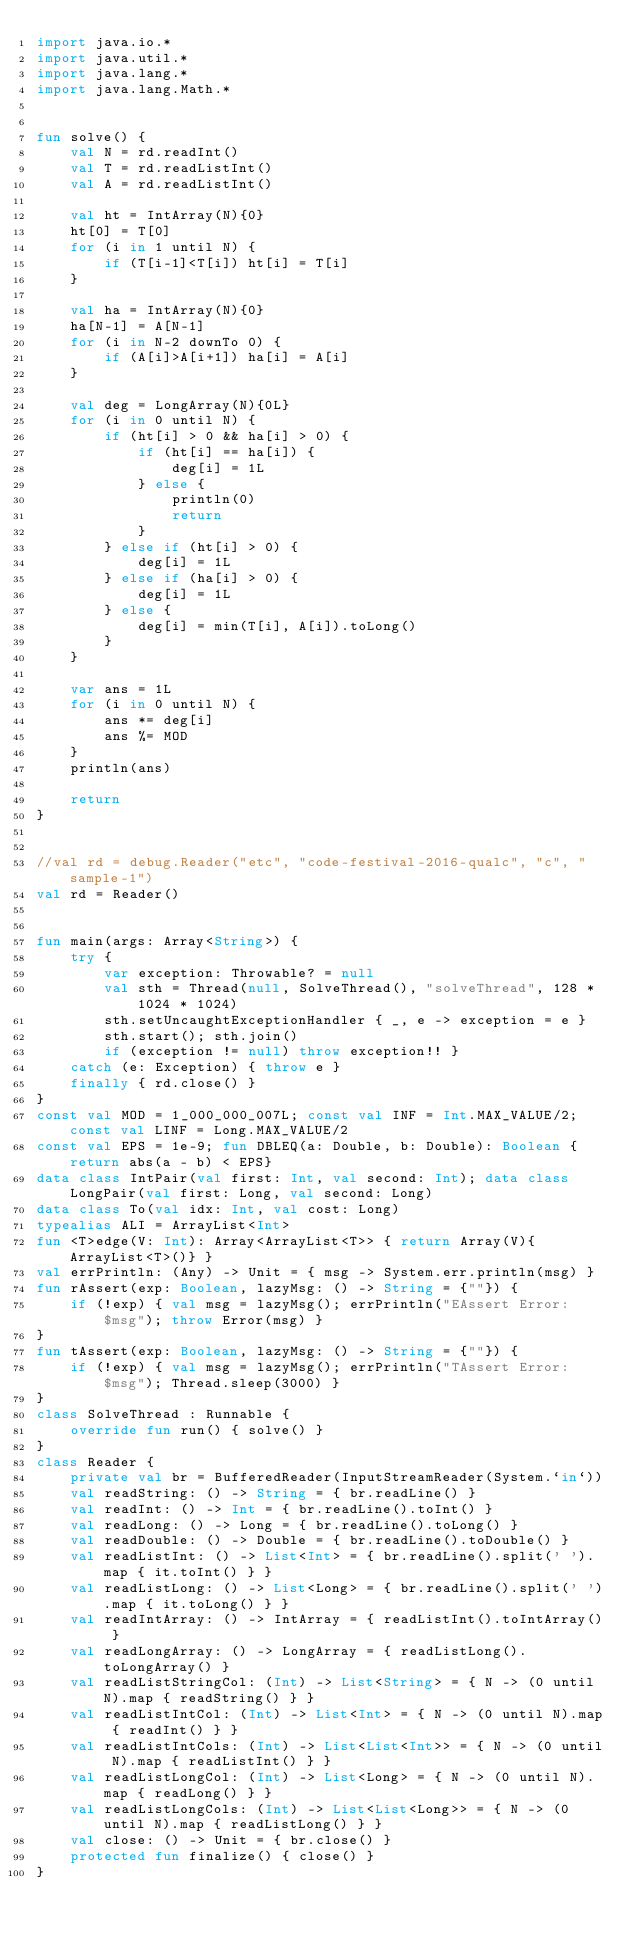Convert code to text. <code><loc_0><loc_0><loc_500><loc_500><_Kotlin_>import java.io.*
import java.util.*
import java.lang.*
import java.lang.Math.*


fun solve() {
    val N = rd.readInt()
    val T = rd.readListInt()
    val A = rd.readListInt()

    val ht = IntArray(N){0}
    ht[0] = T[0]
    for (i in 1 until N) {
        if (T[i-1]<T[i]) ht[i] = T[i]
    }

    val ha = IntArray(N){0}
    ha[N-1] = A[N-1]
    for (i in N-2 downTo 0) {
        if (A[i]>A[i+1]) ha[i] = A[i]
    }

    val deg = LongArray(N){0L}
    for (i in 0 until N) {
        if (ht[i] > 0 && ha[i] > 0) {
            if (ht[i] == ha[i]) {
                deg[i] = 1L
            } else {
                println(0)
                return
            }
        } else if (ht[i] > 0) {
            deg[i] = 1L
        } else if (ha[i] > 0) {
            deg[i] = 1L
        } else {
            deg[i] = min(T[i], A[i]).toLong()
        }
    }

    var ans = 1L
    for (i in 0 until N) {
        ans *= deg[i]
        ans %= MOD
    }
    println(ans)

    return
}


//val rd = debug.Reader("etc", "code-festival-2016-qualc", "c", "sample-1")
val rd = Reader()


fun main(args: Array<String>) {
    try {
        var exception: Throwable? = null
        val sth = Thread(null, SolveThread(), "solveThread", 128 * 1024 * 1024)
        sth.setUncaughtExceptionHandler { _, e -> exception = e }
        sth.start(); sth.join()
        if (exception != null) throw exception!! }
    catch (e: Exception) { throw e }
    finally { rd.close() }
}
const val MOD = 1_000_000_007L; const val INF = Int.MAX_VALUE/2; const val LINF = Long.MAX_VALUE/2
const val EPS = 1e-9; fun DBLEQ(a: Double, b: Double): Boolean {return abs(a - b) < EPS}
data class IntPair(val first: Int, val second: Int); data class LongPair(val first: Long, val second: Long)
data class To(val idx: Int, val cost: Long)
typealias ALI = ArrayList<Int>
fun <T>edge(V: Int): Array<ArrayList<T>> { return Array(V){ArrayList<T>()} }
val errPrintln: (Any) -> Unit = { msg -> System.err.println(msg) }
fun rAssert(exp: Boolean, lazyMsg: () -> String = {""}) {
    if (!exp) { val msg = lazyMsg(); errPrintln("EAssert Error: $msg"); throw Error(msg) }
}
fun tAssert(exp: Boolean, lazyMsg: () -> String = {""}) {
    if (!exp) { val msg = lazyMsg(); errPrintln("TAssert Error: $msg"); Thread.sleep(3000) }
}
class SolveThread : Runnable {
    override fun run() { solve() }
}
class Reader {
    private val br = BufferedReader(InputStreamReader(System.`in`))
    val readString: () -> String = { br.readLine() }
    val readInt: () -> Int = { br.readLine().toInt() }
    val readLong: () -> Long = { br.readLine().toLong() }
    val readDouble: () -> Double = { br.readLine().toDouble() }
    val readListInt: () -> List<Int> = { br.readLine().split(' ').map { it.toInt() } }
    val readListLong: () -> List<Long> = { br.readLine().split(' ').map { it.toLong() } }
    val readIntArray: () -> IntArray = { readListInt().toIntArray() }
    val readLongArray: () -> LongArray = { readListLong().toLongArray() }
    val readListStringCol: (Int) -> List<String> = { N -> (0 until N).map { readString() } }
    val readListIntCol: (Int) -> List<Int> = { N -> (0 until N).map { readInt() } }
    val readListIntCols: (Int) -> List<List<Int>> = { N -> (0 until N).map { readListInt() } }
    val readListLongCol: (Int) -> List<Long> = { N -> (0 until N).map { readLong() } }
    val readListLongCols: (Int) -> List<List<Long>> = { N -> (0 until N).map { readListLong() } }
    val close: () -> Unit = { br.close() }
    protected fun finalize() { close() }
}
</code> 